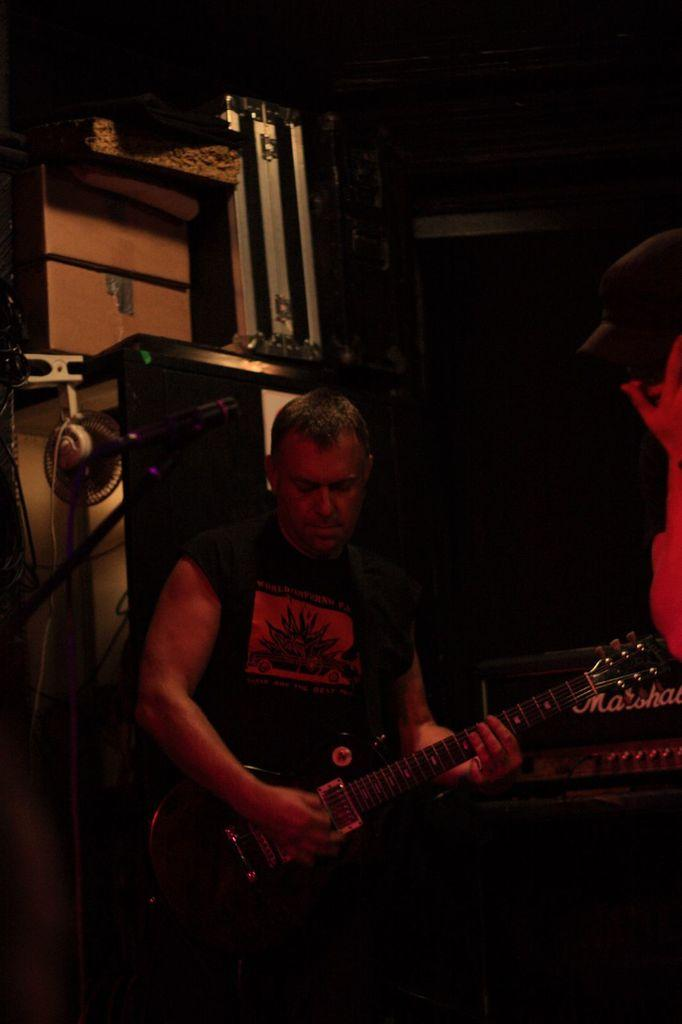Who is present in the image? There is a man in the image. What is the man holding in the image? The man is holding a guitar. What type of haircut does the man have in the image? The provided facts do not mention the man's haircut, so we cannot determine it from the image. 